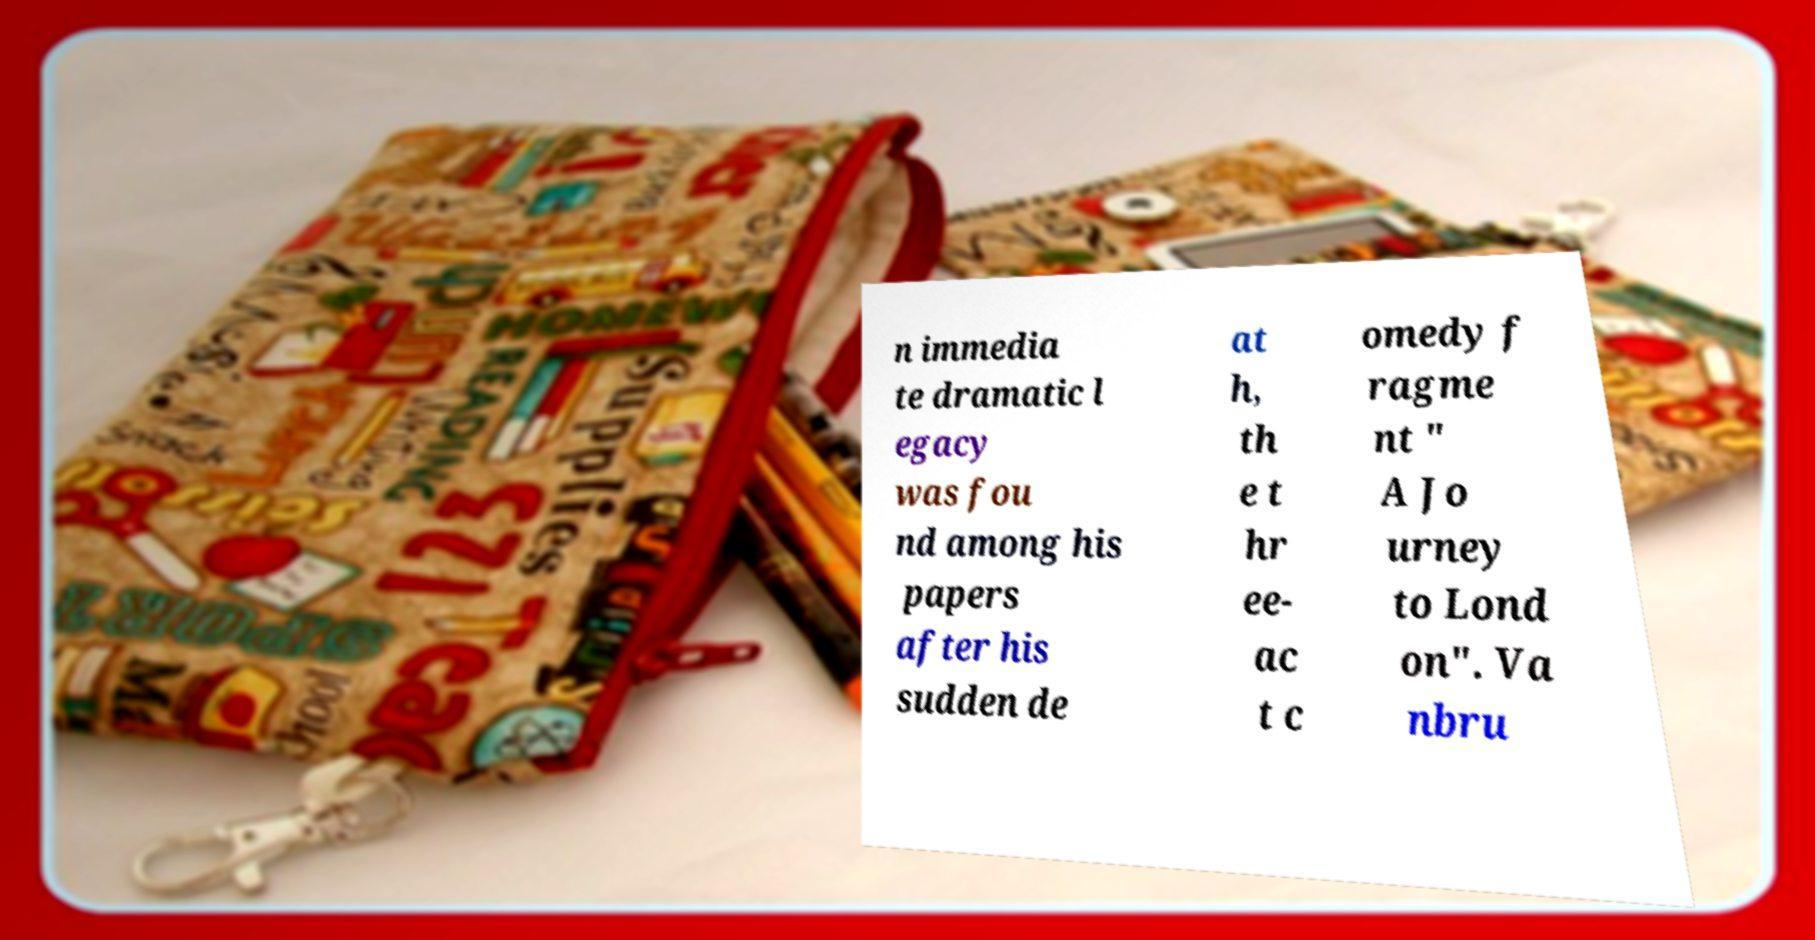Can you read and provide the text displayed in the image?This photo seems to have some interesting text. Can you extract and type it out for me? n immedia te dramatic l egacy was fou nd among his papers after his sudden de at h, th e t hr ee- ac t c omedy f ragme nt " A Jo urney to Lond on". Va nbru 